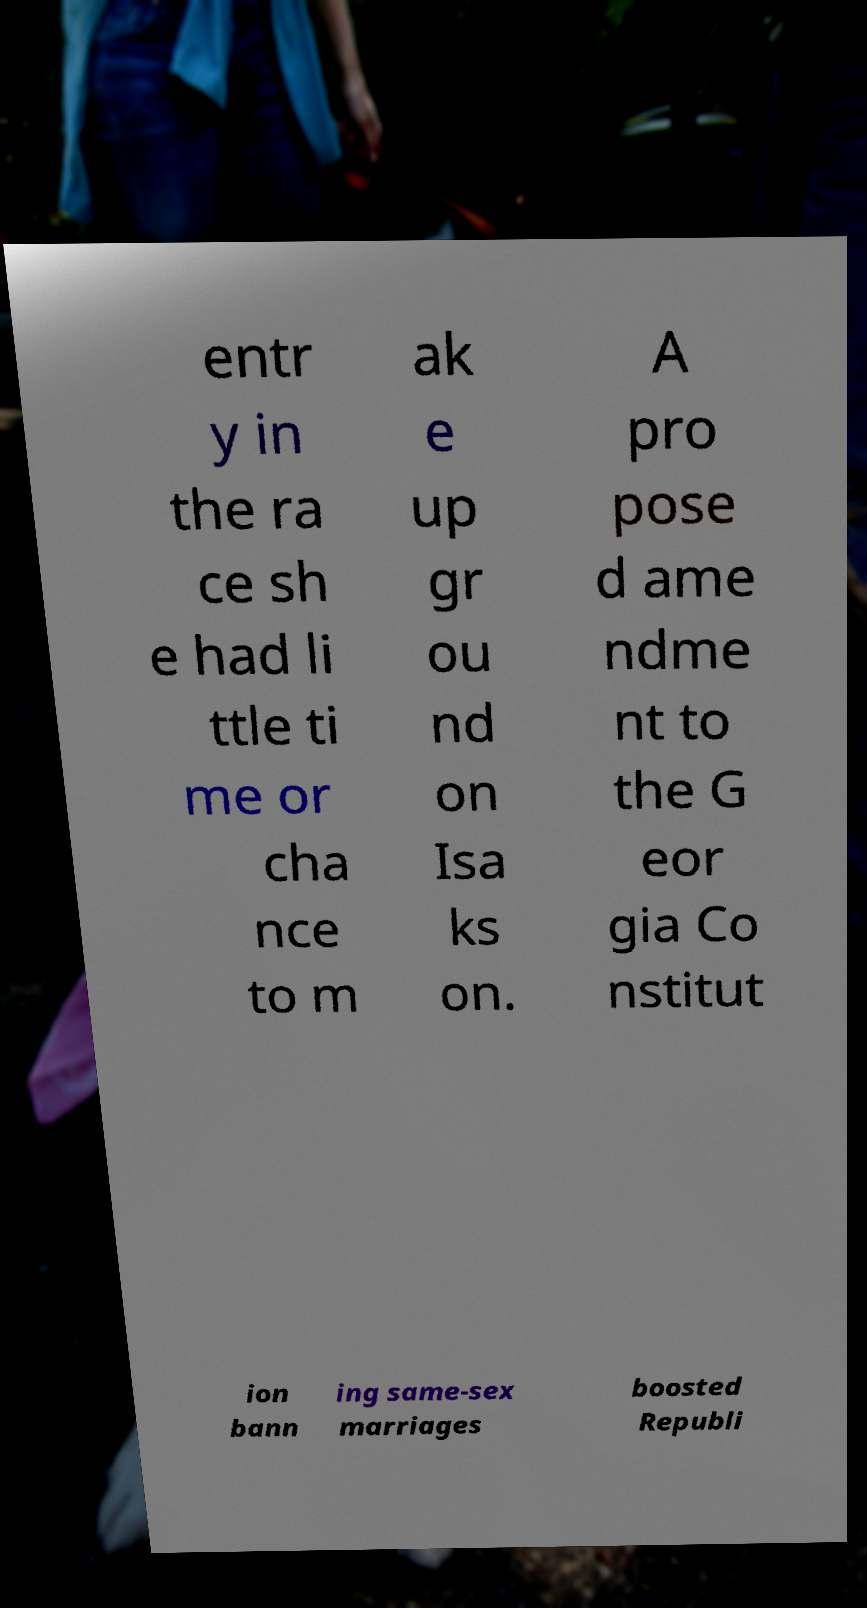I need the written content from this picture converted into text. Can you do that? entr y in the ra ce sh e had li ttle ti me or cha nce to m ak e up gr ou nd on Isa ks on. A pro pose d ame ndme nt to the G eor gia Co nstitut ion bann ing same-sex marriages boosted Republi 